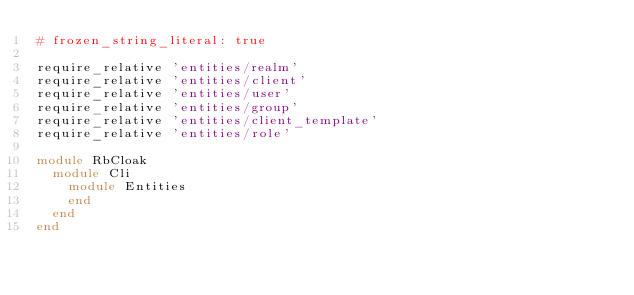Convert code to text. <code><loc_0><loc_0><loc_500><loc_500><_Ruby_># frozen_string_literal: true

require_relative 'entities/realm'
require_relative 'entities/client'
require_relative 'entities/user'
require_relative 'entities/group'
require_relative 'entities/client_template'
require_relative 'entities/role'

module RbCloak
  module Cli
    module Entities
    end
  end
end
</code> 